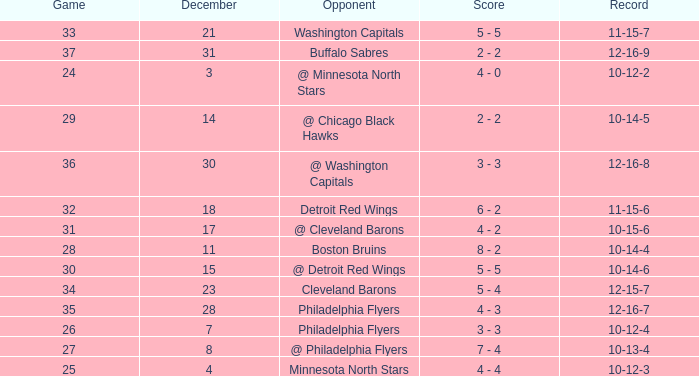What is the lowest December, when Score is "4 - 4"? 4.0. 